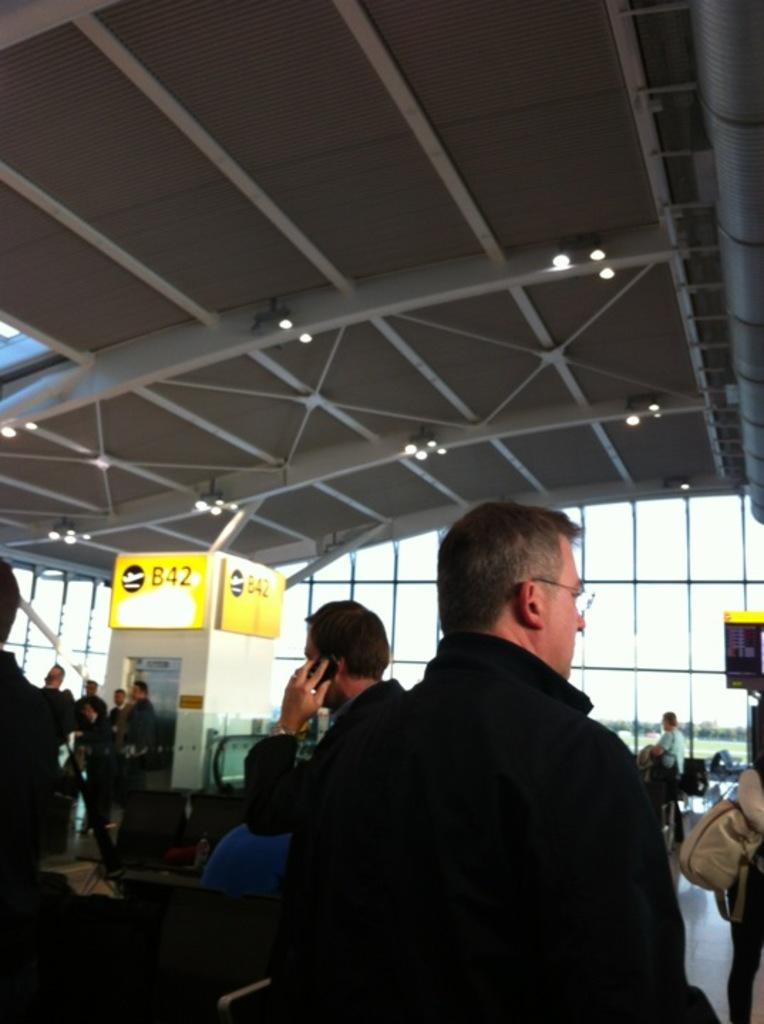What type of location is depicted in the image? The image appears to depict an airport. How many people can be seen in the image? There are many people in the image. Can you describe the man in the front of the image? A man wearing a black jacket is visible in the front of the image. What is visible at the top of the image? There is a roof visible at the top of the image. What type of soap is being used by the parent in the image? There is no soap or parent present in the image; it depicts an airport scene. 